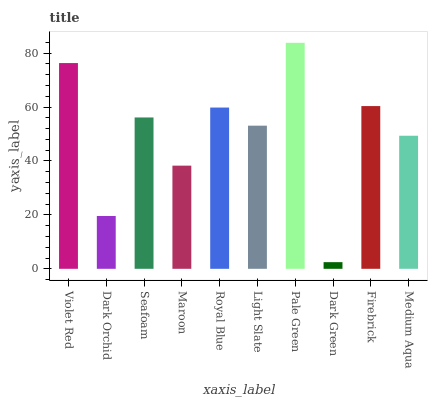Is Dark Orchid the minimum?
Answer yes or no. No. Is Dark Orchid the maximum?
Answer yes or no. No. Is Violet Red greater than Dark Orchid?
Answer yes or no. Yes. Is Dark Orchid less than Violet Red?
Answer yes or no. Yes. Is Dark Orchid greater than Violet Red?
Answer yes or no. No. Is Violet Red less than Dark Orchid?
Answer yes or no. No. Is Seafoam the high median?
Answer yes or no. Yes. Is Light Slate the low median?
Answer yes or no. Yes. Is Light Slate the high median?
Answer yes or no. No. Is Dark Green the low median?
Answer yes or no. No. 